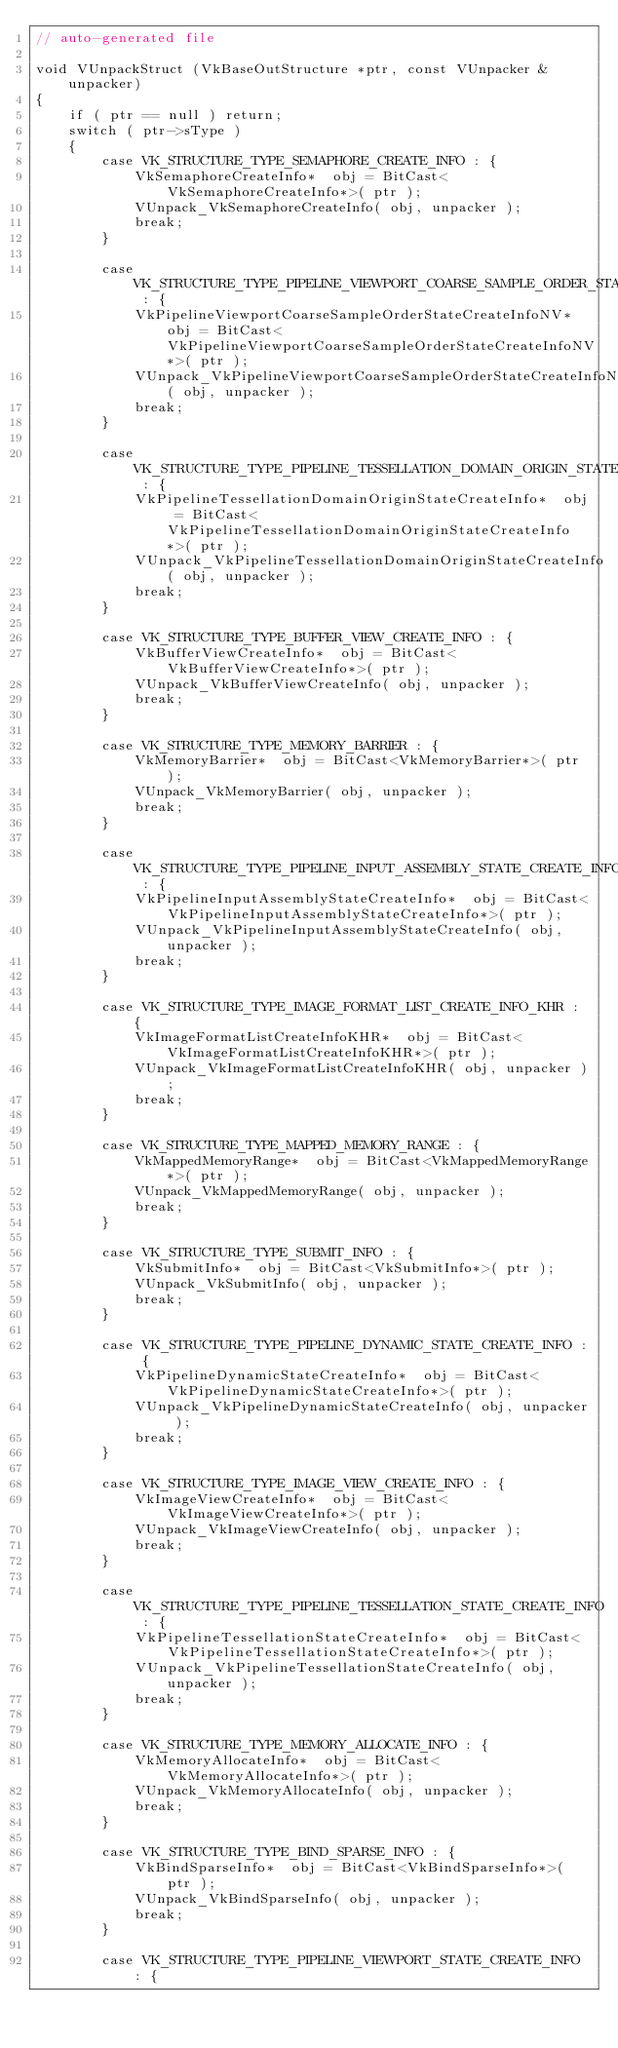Convert code to text. <code><loc_0><loc_0><loc_500><loc_500><_C_>// auto-generated file

void VUnpackStruct (VkBaseOutStructure *ptr, const VUnpacker &unpacker)
{
	if ( ptr == null ) return;
	switch ( ptr->sType )
	{
		case VK_STRUCTURE_TYPE_SEMAPHORE_CREATE_INFO : {
			VkSemaphoreCreateInfo*  obj = BitCast<VkSemaphoreCreateInfo*>( ptr );
			VUnpack_VkSemaphoreCreateInfo( obj, unpacker );
			break;
		}

		case VK_STRUCTURE_TYPE_PIPELINE_VIEWPORT_COARSE_SAMPLE_ORDER_STATE_CREATE_INFO_NV : {
			VkPipelineViewportCoarseSampleOrderStateCreateInfoNV*  obj = BitCast<VkPipelineViewportCoarseSampleOrderStateCreateInfoNV*>( ptr );
			VUnpack_VkPipelineViewportCoarseSampleOrderStateCreateInfoNV( obj, unpacker );
			break;
		}

		case VK_STRUCTURE_TYPE_PIPELINE_TESSELLATION_DOMAIN_ORIGIN_STATE_CREATE_INFO : {
			VkPipelineTessellationDomainOriginStateCreateInfo*  obj = BitCast<VkPipelineTessellationDomainOriginStateCreateInfo*>( ptr );
			VUnpack_VkPipelineTessellationDomainOriginStateCreateInfo( obj, unpacker );
			break;
		}

		case VK_STRUCTURE_TYPE_BUFFER_VIEW_CREATE_INFO : {
			VkBufferViewCreateInfo*  obj = BitCast<VkBufferViewCreateInfo*>( ptr );
			VUnpack_VkBufferViewCreateInfo( obj, unpacker );
			break;
		}

		case VK_STRUCTURE_TYPE_MEMORY_BARRIER : {
			VkMemoryBarrier*  obj = BitCast<VkMemoryBarrier*>( ptr );
			VUnpack_VkMemoryBarrier( obj, unpacker );
			break;
		}

		case VK_STRUCTURE_TYPE_PIPELINE_INPUT_ASSEMBLY_STATE_CREATE_INFO : {
			VkPipelineInputAssemblyStateCreateInfo*  obj = BitCast<VkPipelineInputAssemblyStateCreateInfo*>( ptr );
			VUnpack_VkPipelineInputAssemblyStateCreateInfo( obj, unpacker );
			break;
		}

		case VK_STRUCTURE_TYPE_IMAGE_FORMAT_LIST_CREATE_INFO_KHR : {
			VkImageFormatListCreateInfoKHR*  obj = BitCast<VkImageFormatListCreateInfoKHR*>( ptr );
			VUnpack_VkImageFormatListCreateInfoKHR( obj, unpacker );
			break;
		}

		case VK_STRUCTURE_TYPE_MAPPED_MEMORY_RANGE : {
			VkMappedMemoryRange*  obj = BitCast<VkMappedMemoryRange*>( ptr );
			VUnpack_VkMappedMemoryRange( obj, unpacker );
			break;
		}

		case VK_STRUCTURE_TYPE_SUBMIT_INFO : {
			VkSubmitInfo*  obj = BitCast<VkSubmitInfo*>( ptr );
			VUnpack_VkSubmitInfo( obj, unpacker );
			break;
		}

		case VK_STRUCTURE_TYPE_PIPELINE_DYNAMIC_STATE_CREATE_INFO : {
			VkPipelineDynamicStateCreateInfo*  obj = BitCast<VkPipelineDynamicStateCreateInfo*>( ptr );
			VUnpack_VkPipelineDynamicStateCreateInfo( obj, unpacker );
			break;
		}

		case VK_STRUCTURE_TYPE_IMAGE_VIEW_CREATE_INFO : {
			VkImageViewCreateInfo*  obj = BitCast<VkImageViewCreateInfo*>( ptr );
			VUnpack_VkImageViewCreateInfo( obj, unpacker );
			break;
		}

		case VK_STRUCTURE_TYPE_PIPELINE_TESSELLATION_STATE_CREATE_INFO : {
			VkPipelineTessellationStateCreateInfo*  obj = BitCast<VkPipelineTessellationStateCreateInfo*>( ptr );
			VUnpack_VkPipelineTessellationStateCreateInfo( obj, unpacker );
			break;
		}

		case VK_STRUCTURE_TYPE_MEMORY_ALLOCATE_INFO : {
			VkMemoryAllocateInfo*  obj = BitCast<VkMemoryAllocateInfo*>( ptr );
			VUnpack_VkMemoryAllocateInfo( obj, unpacker );
			break;
		}

		case VK_STRUCTURE_TYPE_BIND_SPARSE_INFO : {
			VkBindSparseInfo*  obj = BitCast<VkBindSparseInfo*>( ptr );
			VUnpack_VkBindSparseInfo( obj, unpacker );
			break;
		}

		case VK_STRUCTURE_TYPE_PIPELINE_VIEWPORT_STATE_CREATE_INFO : {</code> 